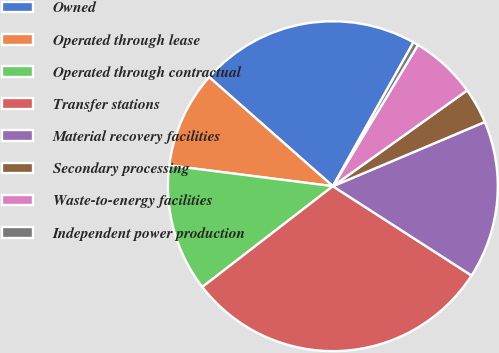<chart> <loc_0><loc_0><loc_500><loc_500><pie_chart><fcel>Owned<fcel>Operated through lease<fcel>Operated through contractual<fcel>Transfer stations<fcel>Material recovery facilities<fcel>Secondary processing<fcel>Waste-to-energy facilities<fcel>Independent power production<nl><fcel>21.62%<fcel>9.49%<fcel>12.48%<fcel>30.43%<fcel>15.47%<fcel>3.5%<fcel>6.5%<fcel>0.51%<nl></chart> 